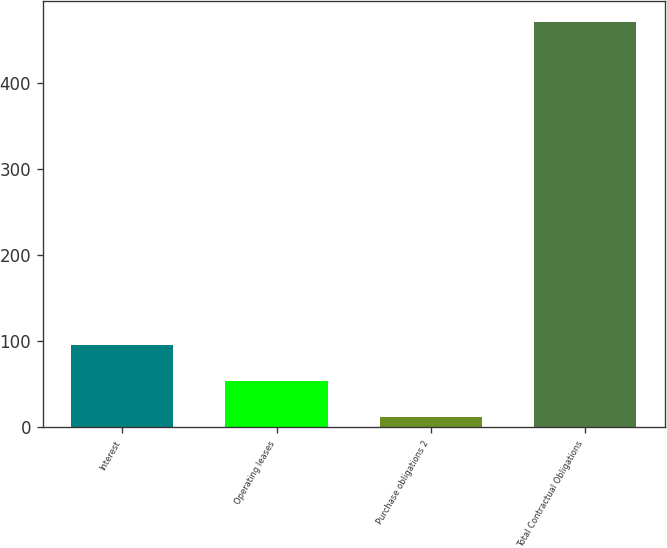Convert chart. <chart><loc_0><loc_0><loc_500><loc_500><bar_chart><fcel>Interest<fcel>Operating leases<fcel>Purchase obligations 2<fcel>Total Contractual Obligations<nl><fcel>95.4<fcel>53.65<fcel>11.9<fcel>471.15<nl></chart> 